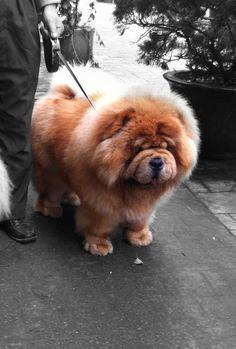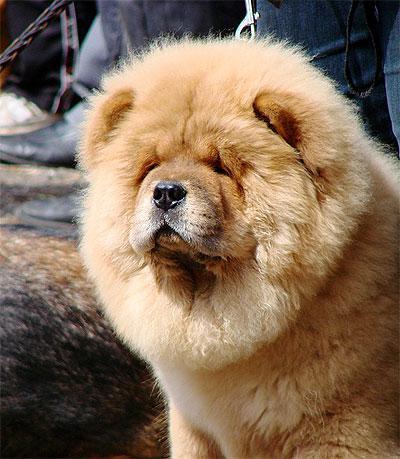The first image is the image on the left, the second image is the image on the right. For the images displayed, is the sentence "A human is holding at least one Chow Chow puppy in their arms." factually correct? Answer yes or no. No. The first image is the image on the left, the second image is the image on the right. Examine the images to the left and right. Is the description "There is a human handling at least one dog in the right image." accurate? Answer yes or no. No. 